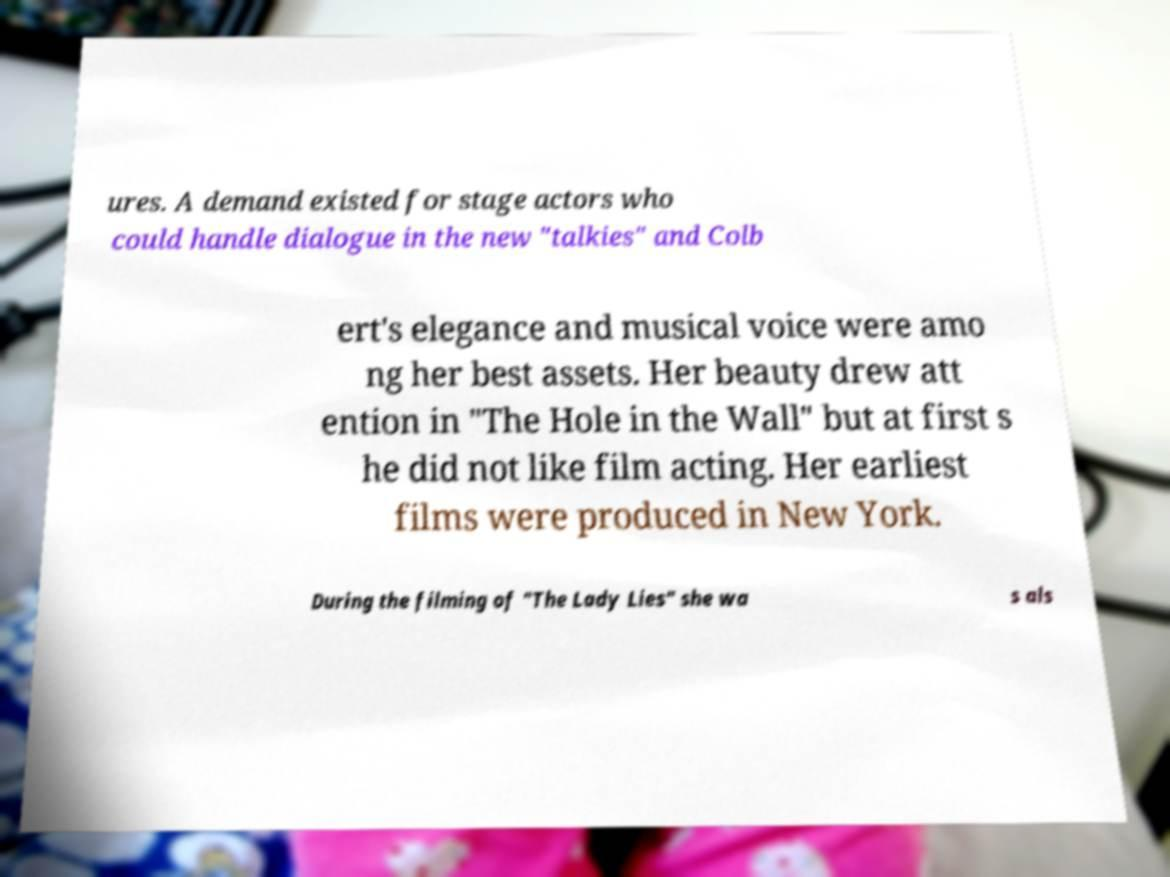Can you accurately transcribe the text from the provided image for me? ures. A demand existed for stage actors who could handle dialogue in the new "talkies" and Colb ert's elegance and musical voice were amo ng her best assets. Her beauty drew att ention in "The Hole in the Wall" but at first s he did not like film acting. Her earliest films were produced in New York. During the filming of "The Lady Lies" she wa s als 